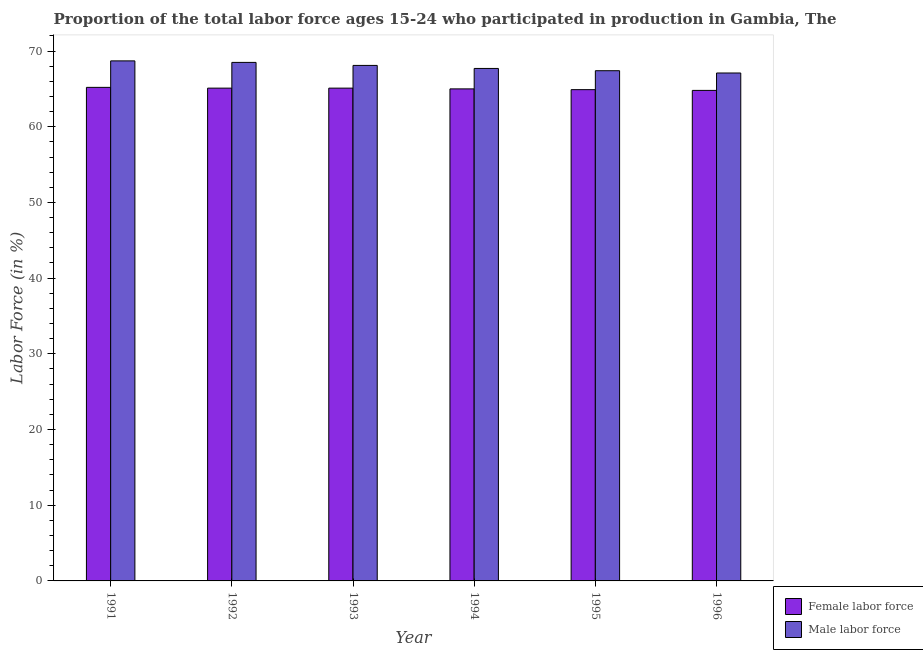Are the number of bars per tick equal to the number of legend labels?
Provide a succinct answer. Yes. Are the number of bars on each tick of the X-axis equal?
Provide a succinct answer. Yes. What is the label of the 5th group of bars from the left?
Keep it short and to the point. 1995. What is the percentage of male labour force in 1996?
Offer a very short reply. 67.1. Across all years, what is the maximum percentage of female labor force?
Your response must be concise. 65.2. Across all years, what is the minimum percentage of female labor force?
Make the answer very short. 64.8. In which year was the percentage of female labor force minimum?
Give a very brief answer. 1996. What is the total percentage of male labour force in the graph?
Offer a terse response. 407.5. What is the difference between the percentage of male labour force in 1992 and that in 1993?
Provide a succinct answer. 0.4. What is the difference between the percentage of female labor force in 1992 and the percentage of male labour force in 1995?
Offer a terse response. 0.2. What is the average percentage of female labor force per year?
Your answer should be compact. 65.02. In how many years, is the percentage of female labor force greater than 52 %?
Make the answer very short. 6. What is the ratio of the percentage of male labour force in 1991 to that in 1992?
Provide a succinct answer. 1. What is the difference between the highest and the second highest percentage of female labor force?
Your answer should be compact. 0.1. What is the difference between the highest and the lowest percentage of male labour force?
Your answer should be very brief. 1.6. What does the 1st bar from the left in 1993 represents?
Offer a terse response. Female labor force. What does the 2nd bar from the right in 1992 represents?
Offer a terse response. Female labor force. How many bars are there?
Make the answer very short. 12. What is the difference between two consecutive major ticks on the Y-axis?
Provide a short and direct response. 10. Does the graph contain any zero values?
Your response must be concise. No. How many legend labels are there?
Your answer should be compact. 2. How are the legend labels stacked?
Your answer should be compact. Vertical. What is the title of the graph?
Make the answer very short. Proportion of the total labor force ages 15-24 who participated in production in Gambia, The. What is the Labor Force (in %) in Female labor force in 1991?
Your answer should be very brief. 65.2. What is the Labor Force (in %) in Male labor force in 1991?
Give a very brief answer. 68.7. What is the Labor Force (in %) in Female labor force in 1992?
Provide a succinct answer. 65.1. What is the Labor Force (in %) in Male labor force in 1992?
Provide a short and direct response. 68.5. What is the Labor Force (in %) of Female labor force in 1993?
Keep it short and to the point. 65.1. What is the Labor Force (in %) of Male labor force in 1993?
Make the answer very short. 68.1. What is the Labor Force (in %) of Male labor force in 1994?
Make the answer very short. 67.7. What is the Labor Force (in %) of Female labor force in 1995?
Provide a short and direct response. 64.9. What is the Labor Force (in %) of Male labor force in 1995?
Give a very brief answer. 67.4. What is the Labor Force (in %) in Female labor force in 1996?
Provide a short and direct response. 64.8. What is the Labor Force (in %) in Male labor force in 1996?
Your response must be concise. 67.1. Across all years, what is the maximum Labor Force (in %) in Female labor force?
Your answer should be compact. 65.2. Across all years, what is the maximum Labor Force (in %) in Male labor force?
Keep it short and to the point. 68.7. Across all years, what is the minimum Labor Force (in %) in Female labor force?
Provide a short and direct response. 64.8. Across all years, what is the minimum Labor Force (in %) in Male labor force?
Offer a very short reply. 67.1. What is the total Labor Force (in %) of Female labor force in the graph?
Make the answer very short. 390.1. What is the total Labor Force (in %) in Male labor force in the graph?
Keep it short and to the point. 407.5. What is the difference between the Labor Force (in %) in Female labor force in 1991 and that in 1992?
Provide a succinct answer. 0.1. What is the difference between the Labor Force (in %) of Female labor force in 1991 and that in 1993?
Provide a short and direct response. 0.1. What is the difference between the Labor Force (in %) of Male labor force in 1991 and that in 1993?
Your answer should be compact. 0.6. What is the difference between the Labor Force (in %) in Male labor force in 1991 and that in 1994?
Make the answer very short. 1. What is the difference between the Labor Force (in %) of Female labor force in 1991 and that in 1996?
Your response must be concise. 0.4. What is the difference between the Labor Force (in %) in Female labor force in 1992 and that in 1996?
Ensure brevity in your answer.  0.3. What is the difference between the Labor Force (in %) in Male labor force in 1992 and that in 1996?
Your response must be concise. 1.4. What is the difference between the Labor Force (in %) in Female labor force in 1993 and that in 1995?
Offer a very short reply. 0.2. What is the difference between the Labor Force (in %) of Female labor force in 1993 and that in 1996?
Your answer should be very brief. 0.3. What is the difference between the Labor Force (in %) in Male labor force in 1993 and that in 1996?
Your answer should be compact. 1. What is the difference between the Labor Force (in %) of Female labor force in 1994 and that in 1995?
Your answer should be very brief. 0.1. What is the difference between the Labor Force (in %) in Male labor force in 1994 and that in 1995?
Offer a terse response. 0.3. What is the difference between the Labor Force (in %) in Male labor force in 1994 and that in 1996?
Offer a terse response. 0.6. What is the difference between the Labor Force (in %) in Female labor force in 1991 and the Labor Force (in %) in Male labor force in 1993?
Offer a terse response. -2.9. What is the difference between the Labor Force (in %) of Female labor force in 1991 and the Labor Force (in %) of Male labor force in 1994?
Make the answer very short. -2.5. What is the difference between the Labor Force (in %) of Female labor force in 1991 and the Labor Force (in %) of Male labor force in 1995?
Ensure brevity in your answer.  -2.2. What is the difference between the Labor Force (in %) of Female labor force in 1992 and the Labor Force (in %) of Male labor force in 1994?
Keep it short and to the point. -2.6. What is the difference between the Labor Force (in %) in Female labor force in 1992 and the Labor Force (in %) in Male labor force in 1995?
Offer a terse response. -2.3. What is the difference between the Labor Force (in %) of Female labor force in 1993 and the Labor Force (in %) of Male labor force in 1994?
Your response must be concise. -2.6. What is the difference between the Labor Force (in %) of Female labor force in 1993 and the Labor Force (in %) of Male labor force in 1995?
Offer a terse response. -2.3. What is the difference between the Labor Force (in %) of Female labor force in 1993 and the Labor Force (in %) of Male labor force in 1996?
Make the answer very short. -2. What is the difference between the Labor Force (in %) in Female labor force in 1994 and the Labor Force (in %) in Male labor force in 1995?
Your answer should be very brief. -2.4. What is the difference between the Labor Force (in %) of Female labor force in 1995 and the Labor Force (in %) of Male labor force in 1996?
Provide a succinct answer. -2.2. What is the average Labor Force (in %) in Female labor force per year?
Your answer should be compact. 65.02. What is the average Labor Force (in %) of Male labor force per year?
Provide a succinct answer. 67.92. In the year 1993, what is the difference between the Labor Force (in %) of Female labor force and Labor Force (in %) of Male labor force?
Your answer should be very brief. -3. In the year 1995, what is the difference between the Labor Force (in %) of Female labor force and Labor Force (in %) of Male labor force?
Your response must be concise. -2.5. In the year 1996, what is the difference between the Labor Force (in %) of Female labor force and Labor Force (in %) of Male labor force?
Give a very brief answer. -2.3. What is the ratio of the Labor Force (in %) in Female labor force in 1991 to that in 1992?
Your answer should be compact. 1. What is the ratio of the Labor Force (in %) of Male labor force in 1991 to that in 1993?
Your response must be concise. 1.01. What is the ratio of the Labor Force (in %) of Male labor force in 1991 to that in 1994?
Offer a terse response. 1.01. What is the ratio of the Labor Force (in %) of Male labor force in 1991 to that in 1995?
Keep it short and to the point. 1.02. What is the ratio of the Labor Force (in %) in Female labor force in 1991 to that in 1996?
Your answer should be compact. 1.01. What is the ratio of the Labor Force (in %) in Male labor force in 1991 to that in 1996?
Keep it short and to the point. 1.02. What is the ratio of the Labor Force (in %) in Male labor force in 1992 to that in 1993?
Keep it short and to the point. 1.01. What is the ratio of the Labor Force (in %) in Female labor force in 1992 to that in 1994?
Your response must be concise. 1. What is the ratio of the Labor Force (in %) of Male labor force in 1992 to that in 1994?
Keep it short and to the point. 1.01. What is the ratio of the Labor Force (in %) of Male labor force in 1992 to that in 1995?
Make the answer very short. 1.02. What is the ratio of the Labor Force (in %) of Male labor force in 1992 to that in 1996?
Make the answer very short. 1.02. What is the ratio of the Labor Force (in %) of Male labor force in 1993 to that in 1994?
Provide a succinct answer. 1.01. What is the ratio of the Labor Force (in %) in Male labor force in 1993 to that in 1995?
Your answer should be very brief. 1.01. What is the ratio of the Labor Force (in %) in Male labor force in 1993 to that in 1996?
Provide a succinct answer. 1.01. What is the ratio of the Labor Force (in %) in Female labor force in 1994 to that in 1995?
Offer a terse response. 1. What is the ratio of the Labor Force (in %) of Male labor force in 1994 to that in 1995?
Offer a very short reply. 1. What is the ratio of the Labor Force (in %) in Female labor force in 1994 to that in 1996?
Give a very brief answer. 1. What is the ratio of the Labor Force (in %) in Male labor force in 1994 to that in 1996?
Ensure brevity in your answer.  1.01. What is the difference between the highest and the lowest Labor Force (in %) in Female labor force?
Offer a terse response. 0.4. 